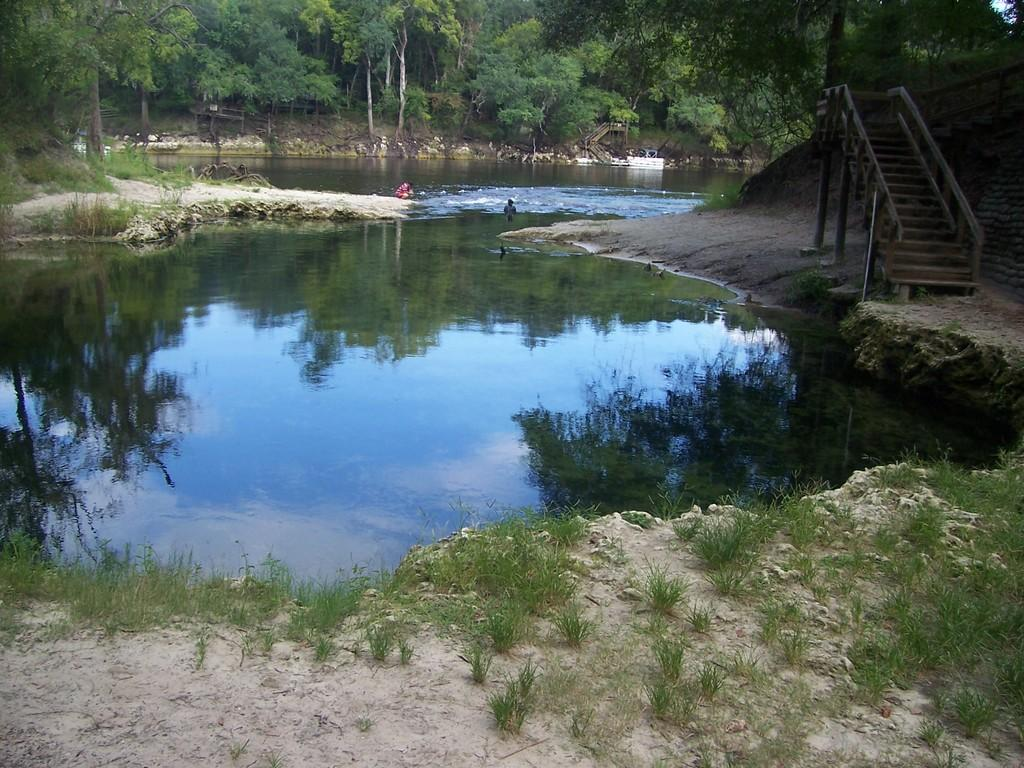What is the primary element visible in the image? There is water in the image. Are there any living beings present in the image? Yes, there are people in the image. What architectural feature can be seen on the right side of the image? There are stairs on the right side of the image. What type of natural scenery is visible in the background of the image? There are trees in the background of the image. What type of scent can be detected coming from the water in the image? There is no indication of a scent in the image, as it only shows water, people, stairs, and trees. 